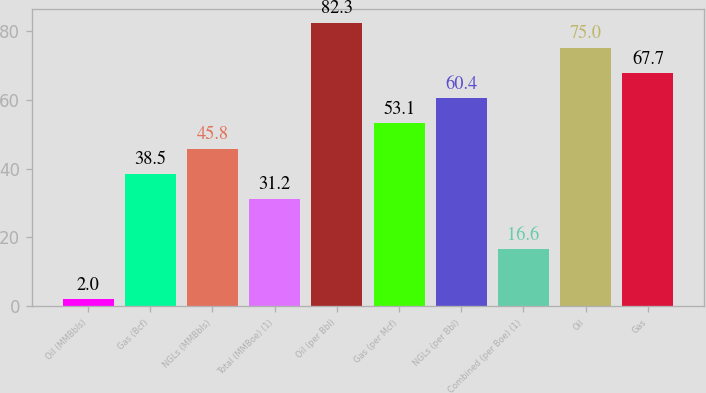<chart> <loc_0><loc_0><loc_500><loc_500><bar_chart><fcel>Oil (MMBbls)<fcel>Gas (Bcf)<fcel>NGLs (MMBbls)<fcel>Total (MMBoe) (1)<fcel>Oil (per Bbl)<fcel>Gas (per Mcf)<fcel>NGLs (per Bbl)<fcel>Combined (per Boe) (1)<fcel>Oil<fcel>Gas<nl><fcel>2<fcel>38.5<fcel>45.8<fcel>31.2<fcel>82.3<fcel>53.1<fcel>60.4<fcel>16.6<fcel>75<fcel>67.7<nl></chart> 